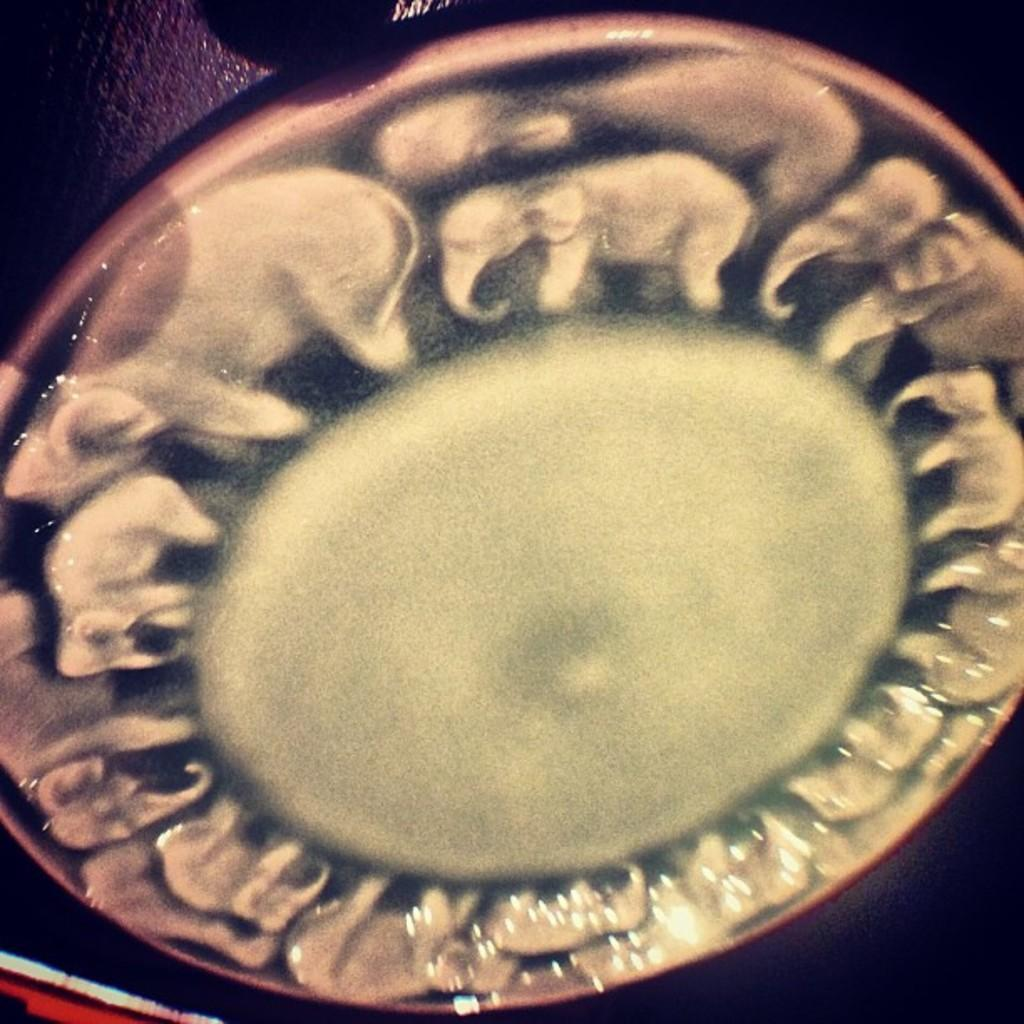What is present on the surface in the image? There is a plate in the image. Can you describe the location of the plate in the image? The plate is placed on a surface. What type of reward is depicted on the plate in the image? There is no reward depicted on the plate in the image; it is simply a plate placed on a surface. 